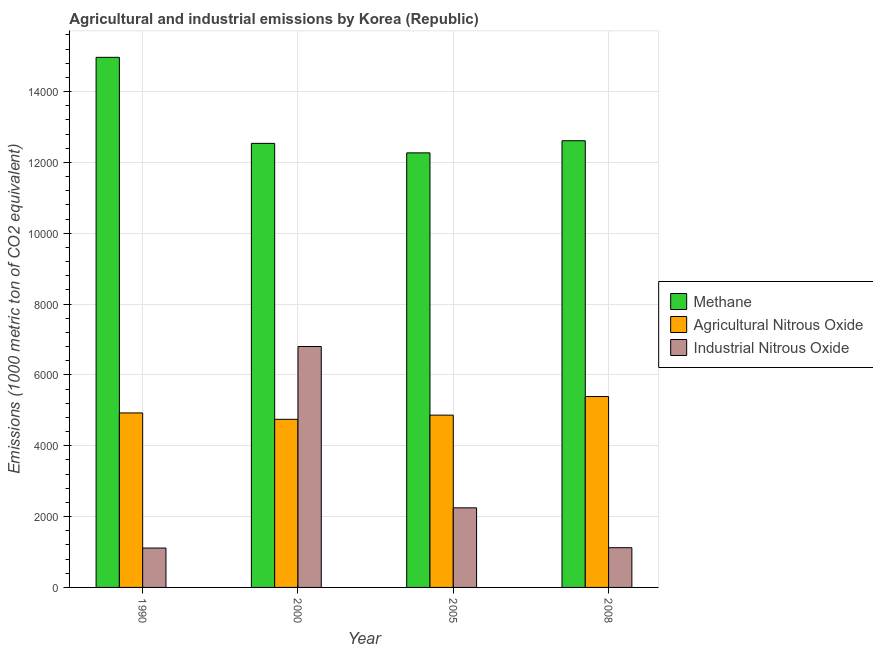How many different coloured bars are there?
Make the answer very short. 3. Are the number of bars on each tick of the X-axis equal?
Give a very brief answer. Yes. How many bars are there on the 2nd tick from the left?
Your response must be concise. 3. How many bars are there on the 1st tick from the right?
Provide a succinct answer. 3. In how many cases, is the number of bars for a given year not equal to the number of legend labels?
Offer a very short reply. 0. What is the amount of agricultural nitrous oxide emissions in 2000?
Your answer should be compact. 4746.8. Across all years, what is the maximum amount of methane emissions?
Your answer should be compact. 1.50e+04. Across all years, what is the minimum amount of industrial nitrous oxide emissions?
Your answer should be very brief. 1112.3. In which year was the amount of agricultural nitrous oxide emissions maximum?
Offer a terse response. 2008. In which year was the amount of industrial nitrous oxide emissions minimum?
Provide a succinct answer. 1990. What is the total amount of agricultural nitrous oxide emissions in the graph?
Keep it short and to the point. 1.99e+04. What is the difference between the amount of industrial nitrous oxide emissions in 1990 and that in 2005?
Your answer should be very brief. -1135.2. What is the difference between the amount of industrial nitrous oxide emissions in 2000 and the amount of agricultural nitrous oxide emissions in 2008?
Offer a very short reply. 5681.1. What is the average amount of agricultural nitrous oxide emissions per year?
Give a very brief answer. 4982.2. In the year 2000, what is the difference between the amount of methane emissions and amount of agricultural nitrous oxide emissions?
Ensure brevity in your answer.  0. In how many years, is the amount of methane emissions greater than 12800 metric ton?
Offer a very short reply. 1. What is the ratio of the amount of agricultural nitrous oxide emissions in 2000 to that in 2008?
Your answer should be compact. 0.88. Is the amount of industrial nitrous oxide emissions in 2000 less than that in 2008?
Offer a terse response. No. What is the difference between the highest and the second highest amount of industrial nitrous oxide emissions?
Your response must be concise. 4555.5. What is the difference between the highest and the lowest amount of methane emissions?
Ensure brevity in your answer.  2697.7. In how many years, is the amount of methane emissions greater than the average amount of methane emissions taken over all years?
Ensure brevity in your answer.  1. Is the sum of the amount of methane emissions in 1990 and 2000 greater than the maximum amount of agricultural nitrous oxide emissions across all years?
Provide a succinct answer. Yes. What does the 2nd bar from the left in 2000 represents?
Keep it short and to the point. Agricultural Nitrous Oxide. What does the 1st bar from the right in 2005 represents?
Your response must be concise. Industrial Nitrous Oxide. What is the difference between two consecutive major ticks on the Y-axis?
Your answer should be compact. 2000. Does the graph contain any zero values?
Ensure brevity in your answer.  No. How many legend labels are there?
Offer a very short reply. 3. What is the title of the graph?
Provide a succinct answer. Agricultural and industrial emissions by Korea (Republic). Does "Agricultural Nitrous Oxide" appear as one of the legend labels in the graph?
Give a very brief answer. Yes. What is the label or title of the Y-axis?
Give a very brief answer. Emissions (1000 metric ton of CO2 equivalent). What is the Emissions (1000 metric ton of CO2 equivalent) in Methane in 1990?
Offer a terse response. 1.50e+04. What is the Emissions (1000 metric ton of CO2 equivalent) of Agricultural Nitrous Oxide in 1990?
Your answer should be compact. 4927.4. What is the Emissions (1000 metric ton of CO2 equivalent) in Industrial Nitrous Oxide in 1990?
Your response must be concise. 1112.3. What is the Emissions (1000 metric ton of CO2 equivalent) in Methane in 2000?
Give a very brief answer. 1.25e+04. What is the Emissions (1000 metric ton of CO2 equivalent) of Agricultural Nitrous Oxide in 2000?
Give a very brief answer. 4746.8. What is the Emissions (1000 metric ton of CO2 equivalent) of Industrial Nitrous Oxide in 2000?
Your answer should be very brief. 6803. What is the Emissions (1000 metric ton of CO2 equivalent) of Methane in 2005?
Offer a very short reply. 1.23e+04. What is the Emissions (1000 metric ton of CO2 equivalent) in Agricultural Nitrous Oxide in 2005?
Make the answer very short. 4865. What is the Emissions (1000 metric ton of CO2 equivalent) in Industrial Nitrous Oxide in 2005?
Make the answer very short. 2247.5. What is the Emissions (1000 metric ton of CO2 equivalent) of Methane in 2008?
Ensure brevity in your answer.  1.26e+04. What is the Emissions (1000 metric ton of CO2 equivalent) of Agricultural Nitrous Oxide in 2008?
Keep it short and to the point. 5389.6. What is the Emissions (1000 metric ton of CO2 equivalent) of Industrial Nitrous Oxide in 2008?
Make the answer very short. 1121.9. Across all years, what is the maximum Emissions (1000 metric ton of CO2 equivalent) in Methane?
Offer a very short reply. 1.50e+04. Across all years, what is the maximum Emissions (1000 metric ton of CO2 equivalent) in Agricultural Nitrous Oxide?
Provide a succinct answer. 5389.6. Across all years, what is the maximum Emissions (1000 metric ton of CO2 equivalent) in Industrial Nitrous Oxide?
Provide a short and direct response. 6803. Across all years, what is the minimum Emissions (1000 metric ton of CO2 equivalent) of Methane?
Give a very brief answer. 1.23e+04. Across all years, what is the minimum Emissions (1000 metric ton of CO2 equivalent) in Agricultural Nitrous Oxide?
Provide a short and direct response. 4746.8. Across all years, what is the minimum Emissions (1000 metric ton of CO2 equivalent) of Industrial Nitrous Oxide?
Offer a terse response. 1112.3. What is the total Emissions (1000 metric ton of CO2 equivalent) of Methane in the graph?
Make the answer very short. 5.24e+04. What is the total Emissions (1000 metric ton of CO2 equivalent) of Agricultural Nitrous Oxide in the graph?
Provide a succinct answer. 1.99e+04. What is the total Emissions (1000 metric ton of CO2 equivalent) of Industrial Nitrous Oxide in the graph?
Ensure brevity in your answer.  1.13e+04. What is the difference between the Emissions (1000 metric ton of CO2 equivalent) in Methane in 1990 and that in 2000?
Give a very brief answer. 2429.6. What is the difference between the Emissions (1000 metric ton of CO2 equivalent) in Agricultural Nitrous Oxide in 1990 and that in 2000?
Offer a very short reply. 180.6. What is the difference between the Emissions (1000 metric ton of CO2 equivalent) of Industrial Nitrous Oxide in 1990 and that in 2000?
Provide a short and direct response. -5690.7. What is the difference between the Emissions (1000 metric ton of CO2 equivalent) in Methane in 1990 and that in 2005?
Make the answer very short. 2697.7. What is the difference between the Emissions (1000 metric ton of CO2 equivalent) of Agricultural Nitrous Oxide in 1990 and that in 2005?
Offer a very short reply. 62.4. What is the difference between the Emissions (1000 metric ton of CO2 equivalent) in Industrial Nitrous Oxide in 1990 and that in 2005?
Your response must be concise. -1135.2. What is the difference between the Emissions (1000 metric ton of CO2 equivalent) of Methane in 1990 and that in 2008?
Ensure brevity in your answer.  2355.3. What is the difference between the Emissions (1000 metric ton of CO2 equivalent) in Agricultural Nitrous Oxide in 1990 and that in 2008?
Your response must be concise. -462.2. What is the difference between the Emissions (1000 metric ton of CO2 equivalent) in Methane in 2000 and that in 2005?
Provide a short and direct response. 268.1. What is the difference between the Emissions (1000 metric ton of CO2 equivalent) in Agricultural Nitrous Oxide in 2000 and that in 2005?
Keep it short and to the point. -118.2. What is the difference between the Emissions (1000 metric ton of CO2 equivalent) in Industrial Nitrous Oxide in 2000 and that in 2005?
Your response must be concise. 4555.5. What is the difference between the Emissions (1000 metric ton of CO2 equivalent) of Methane in 2000 and that in 2008?
Ensure brevity in your answer.  -74.3. What is the difference between the Emissions (1000 metric ton of CO2 equivalent) of Agricultural Nitrous Oxide in 2000 and that in 2008?
Make the answer very short. -642.8. What is the difference between the Emissions (1000 metric ton of CO2 equivalent) in Industrial Nitrous Oxide in 2000 and that in 2008?
Provide a succinct answer. 5681.1. What is the difference between the Emissions (1000 metric ton of CO2 equivalent) in Methane in 2005 and that in 2008?
Offer a very short reply. -342.4. What is the difference between the Emissions (1000 metric ton of CO2 equivalent) of Agricultural Nitrous Oxide in 2005 and that in 2008?
Your answer should be compact. -524.6. What is the difference between the Emissions (1000 metric ton of CO2 equivalent) in Industrial Nitrous Oxide in 2005 and that in 2008?
Offer a very short reply. 1125.6. What is the difference between the Emissions (1000 metric ton of CO2 equivalent) in Methane in 1990 and the Emissions (1000 metric ton of CO2 equivalent) in Agricultural Nitrous Oxide in 2000?
Keep it short and to the point. 1.02e+04. What is the difference between the Emissions (1000 metric ton of CO2 equivalent) of Methane in 1990 and the Emissions (1000 metric ton of CO2 equivalent) of Industrial Nitrous Oxide in 2000?
Offer a very short reply. 8165.7. What is the difference between the Emissions (1000 metric ton of CO2 equivalent) in Agricultural Nitrous Oxide in 1990 and the Emissions (1000 metric ton of CO2 equivalent) in Industrial Nitrous Oxide in 2000?
Offer a very short reply. -1875.6. What is the difference between the Emissions (1000 metric ton of CO2 equivalent) of Methane in 1990 and the Emissions (1000 metric ton of CO2 equivalent) of Agricultural Nitrous Oxide in 2005?
Offer a very short reply. 1.01e+04. What is the difference between the Emissions (1000 metric ton of CO2 equivalent) in Methane in 1990 and the Emissions (1000 metric ton of CO2 equivalent) in Industrial Nitrous Oxide in 2005?
Give a very brief answer. 1.27e+04. What is the difference between the Emissions (1000 metric ton of CO2 equivalent) in Agricultural Nitrous Oxide in 1990 and the Emissions (1000 metric ton of CO2 equivalent) in Industrial Nitrous Oxide in 2005?
Offer a very short reply. 2679.9. What is the difference between the Emissions (1000 metric ton of CO2 equivalent) of Methane in 1990 and the Emissions (1000 metric ton of CO2 equivalent) of Agricultural Nitrous Oxide in 2008?
Keep it short and to the point. 9579.1. What is the difference between the Emissions (1000 metric ton of CO2 equivalent) of Methane in 1990 and the Emissions (1000 metric ton of CO2 equivalent) of Industrial Nitrous Oxide in 2008?
Make the answer very short. 1.38e+04. What is the difference between the Emissions (1000 metric ton of CO2 equivalent) in Agricultural Nitrous Oxide in 1990 and the Emissions (1000 metric ton of CO2 equivalent) in Industrial Nitrous Oxide in 2008?
Ensure brevity in your answer.  3805.5. What is the difference between the Emissions (1000 metric ton of CO2 equivalent) in Methane in 2000 and the Emissions (1000 metric ton of CO2 equivalent) in Agricultural Nitrous Oxide in 2005?
Offer a very short reply. 7674.1. What is the difference between the Emissions (1000 metric ton of CO2 equivalent) of Methane in 2000 and the Emissions (1000 metric ton of CO2 equivalent) of Industrial Nitrous Oxide in 2005?
Your response must be concise. 1.03e+04. What is the difference between the Emissions (1000 metric ton of CO2 equivalent) in Agricultural Nitrous Oxide in 2000 and the Emissions (1000 metric ton of CO2 equivalent) in Industrial Nitrous Oxide in 2005?
Your response must be concise. 2499.3. What is the difference between the Emissions (1000 metric ton of CO2 equivalent) of Methane in 2000 and the Emissions (1000 metric ton of CO2 equivalent) of Agricultural Nitrous Oxide in 2008?
Make the answer very short. 7149.5. What is the difference between the Emissions (1000 metric ton of CO2 equivalent) in Methane in 2000 and the Emissions (1000 metric ton of CO2 equivalent) in Industrial Nitrous Oxide in 2008?
Your answer should be very brief. 1.14e+04. What is the difference between the Emissions (1000 metric ton of CO2 equivalent) in Agricultural Nitrous Oxide in 2000 and the Emissions (1000 metric ton of CO2 equivalent) in Industrial Nitrous Oxide in 2008?
Your answer should be very brief. 3624.9. What is the difference between the Emissions (1000 metric ton of CO2 equivalent) in Methane in 2005 and the Emissions (1000 metric ton of CO2 equivalent) in Agricultural Nitrous Oxide in 2008?
Give a very brief answer. 6881.4. What is the difference between the Emissions (1000 metric ton of CO2 equivalent) of Methane in 2005 and the Emissions (1000 metric ton of CO2 equivalent) of Industrial Nitrous Oxide in 2008?
Keep it short and to the point. 1.11e+04. What is the difference between the Emissions (1000 metric ton of CO2 equivalent) in Agricultural Nitrous Oxide in 2005 and the Emissions (1000 metric ton of CO2 equivalent) in Industrial Nitrous Oxide in 2008?
Provide a short and direct response. 3743.1. What is the average Emissions (1000 metric ton of CO2 equivalent) in Methane per year?
Offer a terse response. 1.31e+04. What is the average Emissions (1000 metric ton of CO2 equivalent) of Agricultural Nitrous Oxide per year?
Offer a very short reply. 4982.2. What is the average Emissions (1000 metric ton of CO2 equivalent) in Industrial Nitrous Oxide per year?
Your response must be concise. 2821.18. In the year 1990, what is the difference between the Emissions (1000 metric ton of CO2 equivalent) of Methane and Emissions (1000 metric ton of CO2 equivalent) of Agricultural Nitrous Oxide?
Your response must be concise. 1.00e+04. In the year 1990, what is the difference between the Emissions (1000 metric ton of CO2 equivalent) of Methane and Emissions (1000 metric ton of CO2 equivalent) of Industrial Nitrous Oxide?
Ensure brevity in your answer.  1.39e+04. In the year 1990, what is the difference between the Emissions (1000 metric ton of CO2 equivalent) of Agricultural Nitrous Oxide and Emissions (1000 metric ton of CO2 equivalent) of Industrial Nitrous Oxide?
Ensure brevity in your answer.  3815.1. In the year 2000, what is the difference between the Emissions (1000 metric ton of CO2 equivalent) in Methane and Emissions (1000 metric ton of CO2 equivalent) in Agricultural Nitrous Oxide?
Your answer should be very brief. 7792.3. In the year 2000, what is the difference between the Emissions (1000 metric ton of CO2 equivalent) in Methane and Emissions (1000 metric ton of CO2 equivalent) in Industrial Nitrous Oxide?
Give a very brief answer. 5736.1. In the year 2000, what is the difference between the Emissions (1000 metric ton of CO2 equivalent) in Agricultural Nitrous Oxide and Emissions (1000 metric ton of CO2 equivalent) in Industrial Nitrous Oxide?
Your answer should be very brief. -2056.2. In the year 2005, what is the difference between the Emissions (1000 metric ton of CO2 equivalent) of Methane and Emissions (1000 metric ton of CO2 equivalent) of Agricultural Nitrous Oxide?
Keep it short and to the point. 7406. In the year 2005, what is the difference between the Emissions (1000 metric ton of CO2 equivalent) in Methane and Emissions (1000 metric ton of CO2 equivalent) in Industrial Nitrous Oxide?
Provide a short and direct response. 1.00e+04. In the year 2005, what is the difference between the Emissions (1000 metric ton of CO2 equivalent) in Agricultural Nitrous Oxide and Emissions (1000 metric ton of CO2 equivalent) in Industrial Nitrous Oxide?
Offer a terse response. 2617.5. In the year 2008, what is the difference between the Emissions (1000 metric ton of CO2 equivalent) of Methane and Emissions (1000 metric ton of CO2 equivalent) of Agricultural Nitrous Oxide?
Offer a terse response. 7223.8. In the year 2008, what is the difference between the Emissions (1000 metric ton of CO2 equivalent) of Methane and Emissions (1000 metric ton of CO2 equivalent) of Industrial Nitrous Oxide?
Provide a short and direct response. 1.15e+04. In the year 2008, what is the difference between the Emissions (1000 metric ton of CO2 equivalent) in Agricultural Nitrous Oxide and Emissions (1000 metric ton of CO2 equivalent) in Industrial Nitrous Oxide?
Make the answer very short. 4267.7. What is the ratio of the Emissions (1000 metric ton of CO2 equivalent) of Methane in 1990 to that in 2000?
Your response must be concise. 1.19. What is the ratio of the Emissions (1000 metric ton of CO2 equivalent) of Agricultural Nitrous Oxide in 1990 to that in 2000?
Provide a succinct answer. 1.04. What is the ratio of the Emissions (1000 metric ton of CO2 equivalent) in Industrial Nitrous Oxide in 1990 to that in 2000?
Provide a short and direct response. 0.16. What is the ratio of the Emissions (1000 metric ton of CO2 equivalent) of Methane in 1990 to that in 2005?
Offer a very short reply. 1.22. What is the ratio of the Emissions (1000 metric ton of CO2 equivalent) in Agricultural Nitrous Oxide in 1990 to that in 2005?
Your answer should be compact. 1.01. What is the ratio of the Emissions (1000 metric ton of CO2 equivalent) of Industrial Nitrous Oxide in 1990 to that in 2005?
Give a very brief answer. 0.49. What is the ratio of the Emissions (1000 metric ton of CO2 equivalent) in Methane in 1990 to that in 2008?
Your response must be concise. 1.19. What is the ratio of the Emissions (1000 metric ton of CO2 equivalent) of Agricultural Nitrous Oxide in 1990 to that in 2008?
Your response must be concise. 0.91. What is the ratio of the Emissions (1000 metric ton of CO2 equivalent) in Methane in 2000 to that in 2005?
Your response must be concise. 1.02. What is the ratio of the Emissions (1000 metric ton of CO2 equivalent) in Agricultural Nitrous Oxide in 2000 to that in 2005?
Make the answer very short. 0.98. What is the ratio of the Emissions (1000 metric ton of CO2 equivalent) in Industrial Nitrous Oxide in 2000 to that in 2005?
Provide a succinct answer. 3.03. What is the ratio of the Emissions (1000 metric ton of CO2 equivalent) in Methane in 2000 to that in 2008?
Give a very brief answer. 0.99. What is the ratio of the Emissions (1000 metric ton of CO2 equivalent) of Agricultural Nitrous Oxide in 2000 to that in 2008?
Provide a short and direct response. 0.88. What is the ratio of the Emissions (1000 metric ton of CO2 equivalent) of Industrial Nitrous Oxide in 2000 to that in 2008?
Provide a succinct answer. 6.06. What is the ratio of the Emissions (1000 metric ton of CO2 equivalent) of Methane in 2005 to that in 2008?
Keep it short and to the point. 0.97. What is the ratio of the Emissions (1000 metric ton of CO2 equivalent) of Agricultural Nitrous Oxide in 2005 to that in 2008?
Make the answer very short. 0.9. What is the ratio of the Emissions (1000 metric ton of CO2 equivalent) in Industrial Nitrous Oxide in 2005 to that in 2008?
Offer a terse response. 2. What is the difference between the highest and the second highest Emissions (1000 metric ton of CO2 equivalent) of Methane?
Provide a succinct answer. 2355.3. What is the difference between the highest and the second highest Emissions (1000 metric ton of CO2 equivalent) in Agricultural Nitrous Oxide?
Keep it short and to the point. 462.2. What is the difference between the highest and the second highest Emissions (1000 metric ton of CO2 equivalent) of Industrial Nitrous Oxide?
Give a very brief answer. 4555.5. What is the difference between the highest and the lowest Emissions (1000 metric ton of CO2 equivalent) of Methane?
Your answer should be very brief. 2697.7. What is the difference between the highest and the lowest Emissions (1000 metric ton of CO2 equivalent) in Agricultural Nitrous Oxide?
Keep it short and to the point. 642.8. What is the difference between the highest and the lowest Emissions (1000 metric ton of CO2 equivalent) in Industrial Nitrous Oxide?
Offer a terse response. 5690.7. 